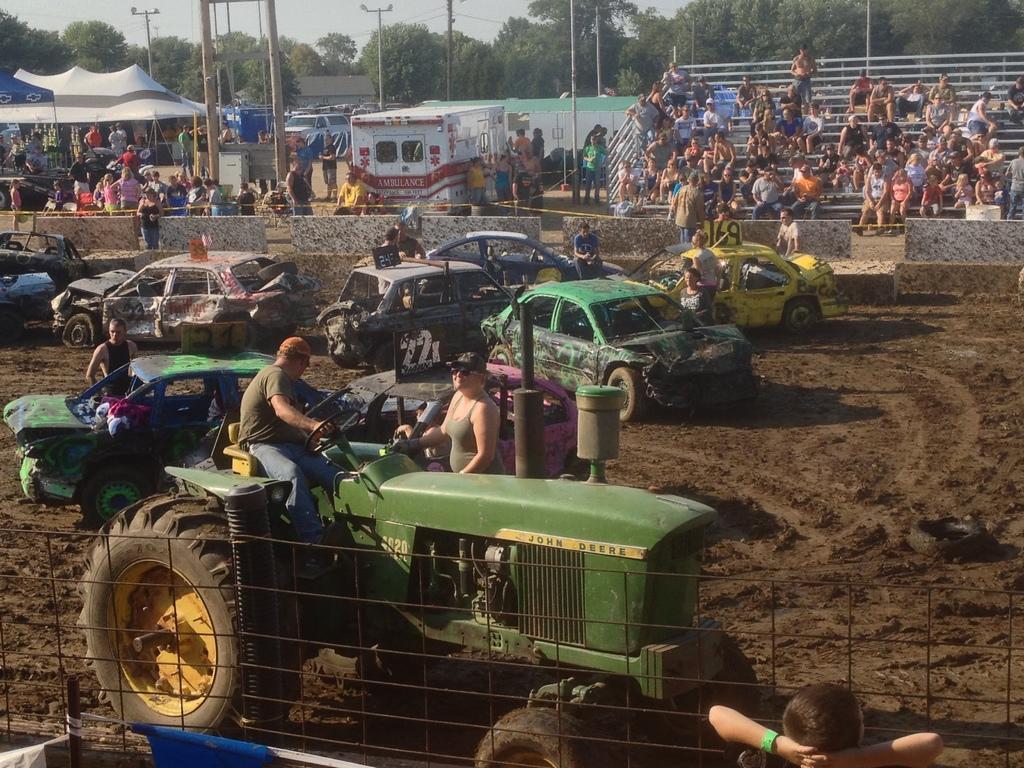Please provide a concise description of this image. There are vehicles and this is a fence. Here we can see crows, poles, trees, tents, and a wall. In the background there is sky. 